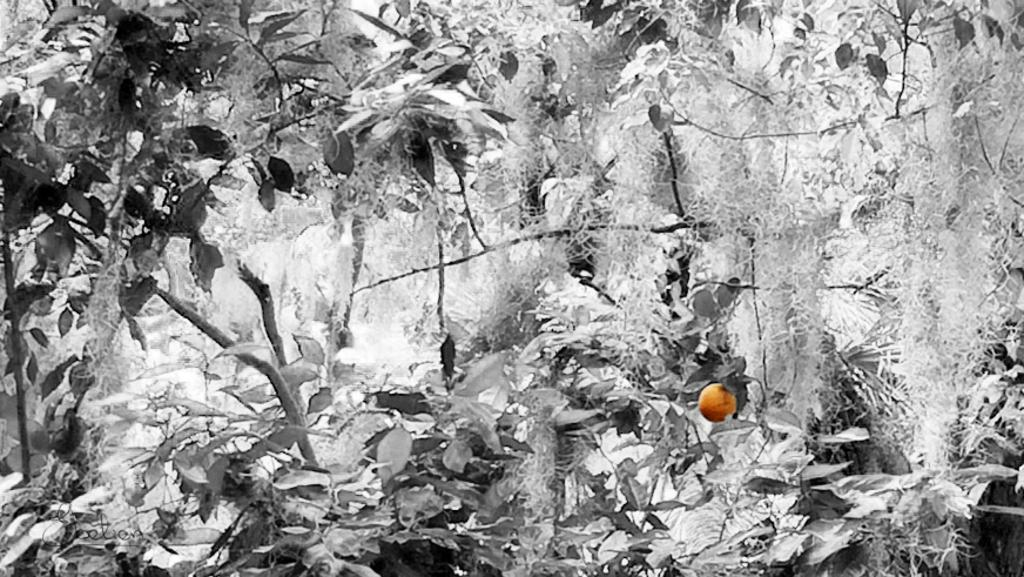What can be observed about the image's appearance? The image is edited. What type of natural elements can be seen in the image? There are trees in the image. What type of fruit is present in the image? There is an orange-colored fruit in the image. What type of floor can be seen in the image? There is no floor visible in the image; it primarily features trees and an orange-colored fruit. Can you tell me the credit score of the person in the image? There is no person present in the image, so it is not possible to determine their credit score. 